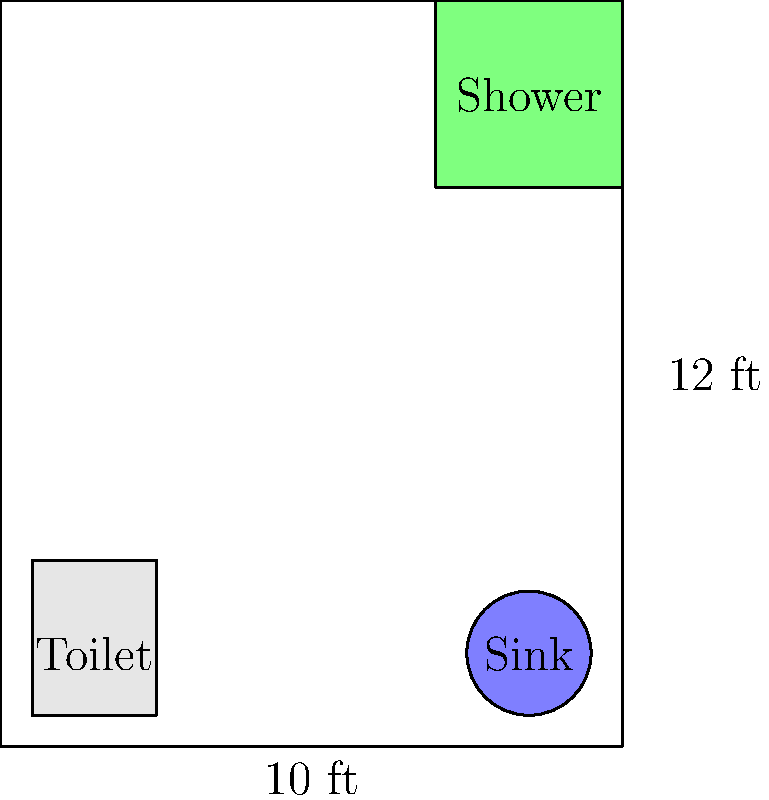In designing an accessible bathroom, you need to optimize the layout for ease of movement and safety. Given the rectangular bathroom with dimensions 10 ft x 12 ft, containing a toilet (2 ft x 2.5 ft), a circular sink (2 ft diameter), and a square shower (3 ft x 3 ft) as shown in the diagram, what is the maximum possible turning radius for a wheelchair in the center of the room? Assume the wheelchair requires a circular area for turning. To find the maximum possible turning radius for a wheelchair, we need to follow these steps:

1. Identify the usable space:
   - Room dimensions: 10 ft x 12 ft
   - Toilet: 2 ft x 2.5 ft (in the bottom-left corner)
   - Sink: 2 ft diameter (near the right wall)
   - Shower: 3 ft x 3 ft (in the top-right corner)

2. Determine the constraints:
   - The turning circle should not overlap with any fixtures.
   - The circle should be centered in the room for optimal accessibility.

3. Calculate the available space:
   - Width: 10 ft - 2 ft (toilet width) = 8 ft
   - Length: 12 ft - 3 ft (shower depth) = 9 ft

4. Find the maximum radius:
   - The radius will be half of the shorter available dimension.
   - Maximum radius = 8 ft / 2 = 4 ft

5. Verify the turning circle fits:
   - The 4 ft radius circle centered in the room will not overlap with any fixtures.
   - It provides sufficient clearance from the toilet, sink, and shower.

Therefore, the maximum possible turning radius for a wheelchair in the center of the room is 4 ft.
Answer: 4 ft 